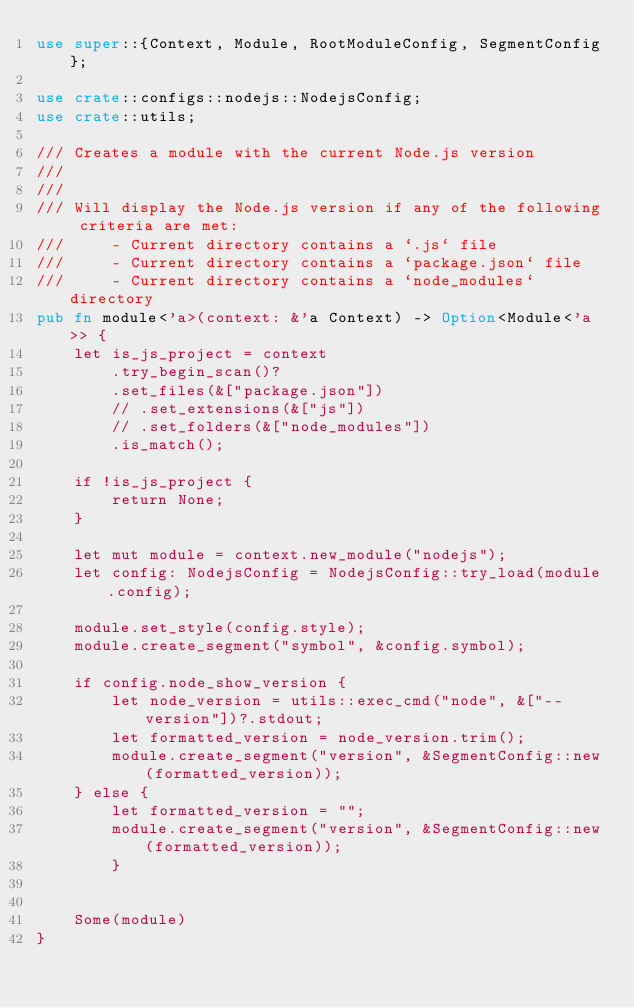Convert code to text. <code><loc_0><loc_0><loc_500><loc_500><_Rust_>use super::{Context, Module, RootModuleConfig, SegmentConfig};

use crate::configs::nodejs::NodejsConfig;
use crate::utils;

/// Creates a module with the current Node.js version
///
///
/// Will display the Node.js version if any of the following criteria are met:
///     - Current directory contains a `.js` file
///     - Current directory contains a `package.json` file
///     - Current directory contains a `node_modules` directory
pub fn module<'a>(context: &'a Context) -> Option<Module<'a>> {
    let is_js_project = context
        .try_begin_scan()?
        .set_files(&["package.json"])
        // .set_extensions(&["js"])
        // .set_folders(&["node_modules"])
        .is_match();

    if !is_js_project {
        return None;
    }

    let mut module = context.new_module("nodejs");
    let config: NodejsConfig = NodejsConfig::try_load(module.config);
    
    module.set_style(config.style);
    module.create_segment("symbol", &config.symbol);
    
    if config.node_show_version {
        let node_version = utils::exec_cmd("node", &["--version"])?.stdout;
        let formatted_version = node_version.trim();
        module.create_segment("version", &SegmentConfig::new(formatted_version));
    } else {
        let formatted_version = "";
        module.create_segment("version", &SegmentConfig::new(formatted_version));
        }


    Some(module)
}
</code> 